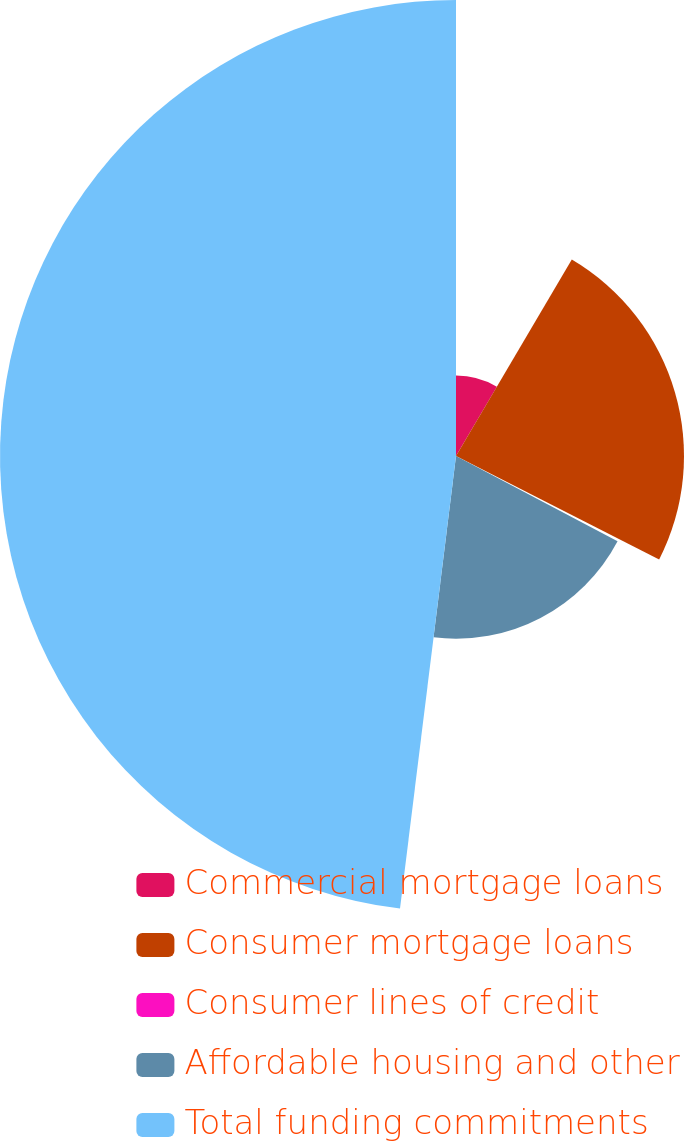<chart> <loc_0><loc_0><loc_500><loc_500><pie_chart><fcel>Commercial mortgage loans<fcel>Consumer mortgage loans<fcel>Consumer lines of credit<fcel>Affordable housing and other<fcel>Total funding commitments<nl><fcel>8.48%<fcel>24.02%<fcel>0.22%<fcel>19.24%<fcel>48.04%<nl></chart> 